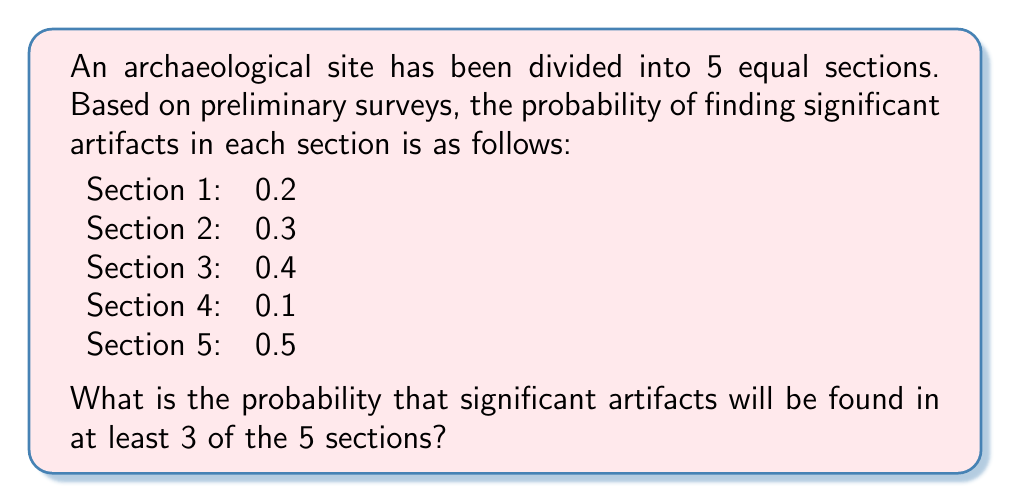Help me with this question. To solve this problem, we can use the concept of complementary events and the binomial probability distribution.

Let's define the event A as "significant artifacts found in at least 3 sections".
The complementary event, not A, would be "significant artifacts found in 0, 1, or 2 sections".

We can calculate P(not A) and then use the fact that P(A) = 1 - P(not A).

Step 1: Calculate the probability for each section
P(success) for each section is given. P(failure) = 1 - P(success)

Section 1: P(success) = 0.2, P(failure) = 0.8
Section 2: P(success) = 0.3, P(failure) = 0.7
Section 3: P(success) = 0.4, P(failure) = 0.6
Section 4: P(success) = 0.1, P(failure) = 0.9
Section 5: P(success) = 0.5, P(failure) = 0.5

Step 2: Use the binomial probability formula to calculate P(X = k) for k = 0, 1, and 2

The formula is:
$$ P(X = k) = \binom{n}{k} p^k (1-p)^{n-k} $$

Where n = 5 (total sections), k is the number of successes, and p is the probability of success.

For k = 0:
$$ P(X = 0) = (0.8 * 0.7 * 0.6 * 0.9 * 0.5) = 0.1512 $$

For k = 1:
$$ P(X = 1) = (0.2 * 0.7 * 0.6 * 0.9 * 0.5) + (0.8 * 0.3 * 0.6 * 0.9 * 0.5) + (0.8 * 0.7 * 0.4 * 0.9 * 0.5) + (0.8 * 0.7 * 0.6 * 0.1 * 0.5) + (0.8 * 0.7 * 0.6 * 0.9 * 0.5) = 0.2726 $$

For k = 2:
$$ P(X = 2) = \binom{5}{2} * (0.2 * 0.3 * 0.6 * 0.9 * 0.5 + 0.2 * 0.3 * 0.4 * 0.9 * 0.5 + 0.2 * 0.3 * 0.6 * 0.1 * 0.5 + 0.2 * 0.7 * 0.4 * 0.1 * 0.5 + 0.8 * 0.3 * 0.4 * 0.1 * 0.5) = 0.3012 $$

Step 3: Calculate P(not A)
$$ P(\text{not A}) = P(X = 0) + P(X = 1) + P(X = 2) = 0.1512 + 0.2726 + 0.3012 = 0.725 $$

Step 4: Calculate P(A)
$$ P(A) = 1 - P(\text{not A}) = 1 - 0.725 = 0.275 $$

Therefore, the probability of finding significant artifacts in at least 3 of the 5 sections is 0.275 or 27.5%.
Answer: 0.275 or 27.5% 